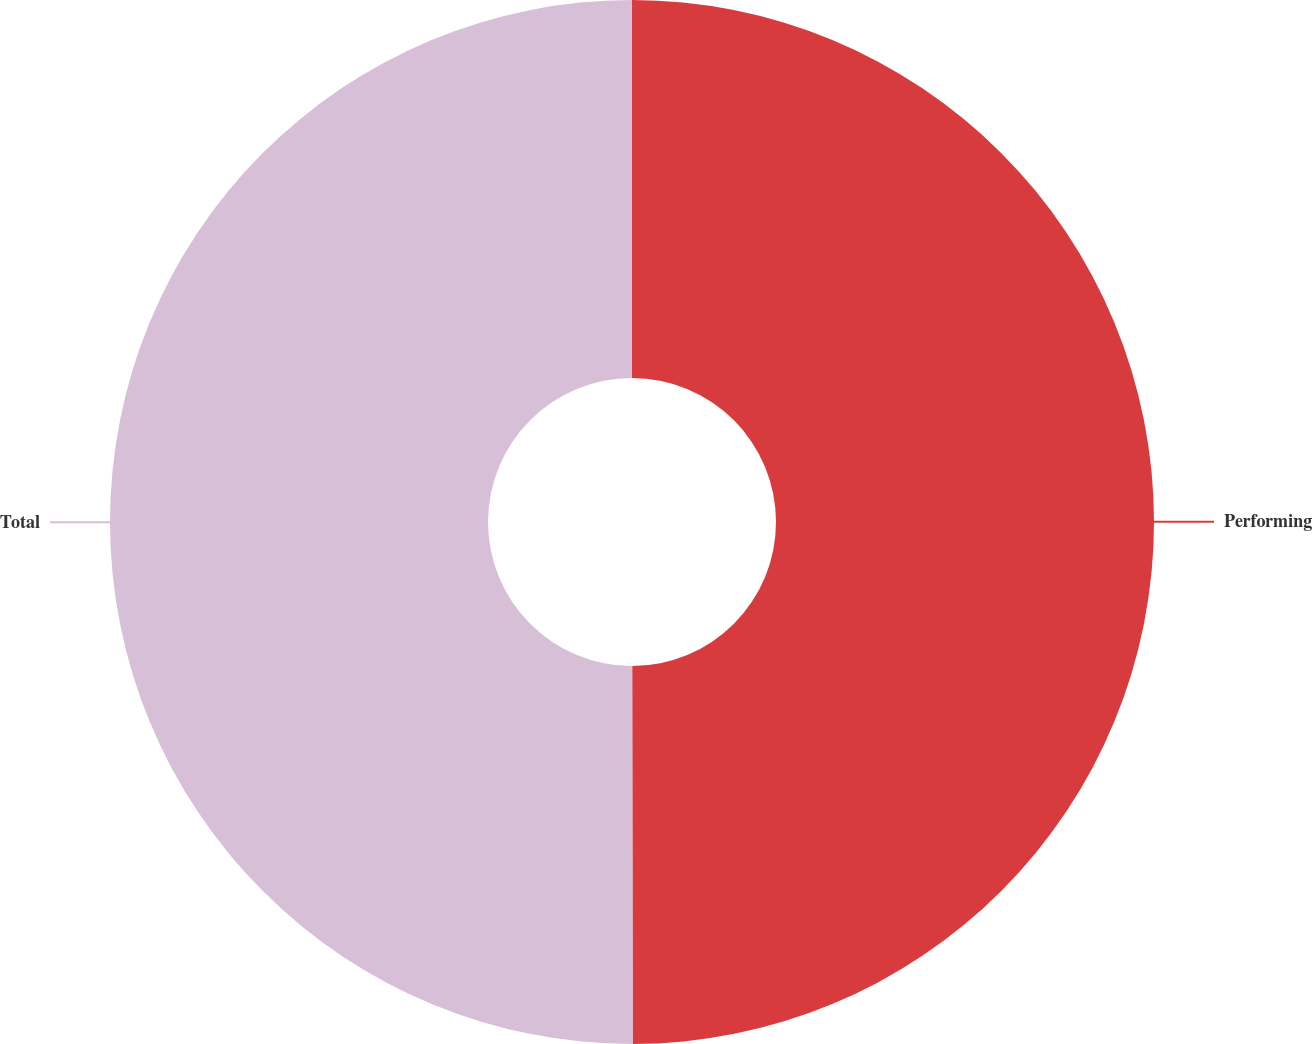<chart> <loc_0><loc_0><loc_500><loc_500><pie_chart><fcel>Performing<fcel>Total<nl><fcel>49.98%<fcel>50.02%<nl></chart> 